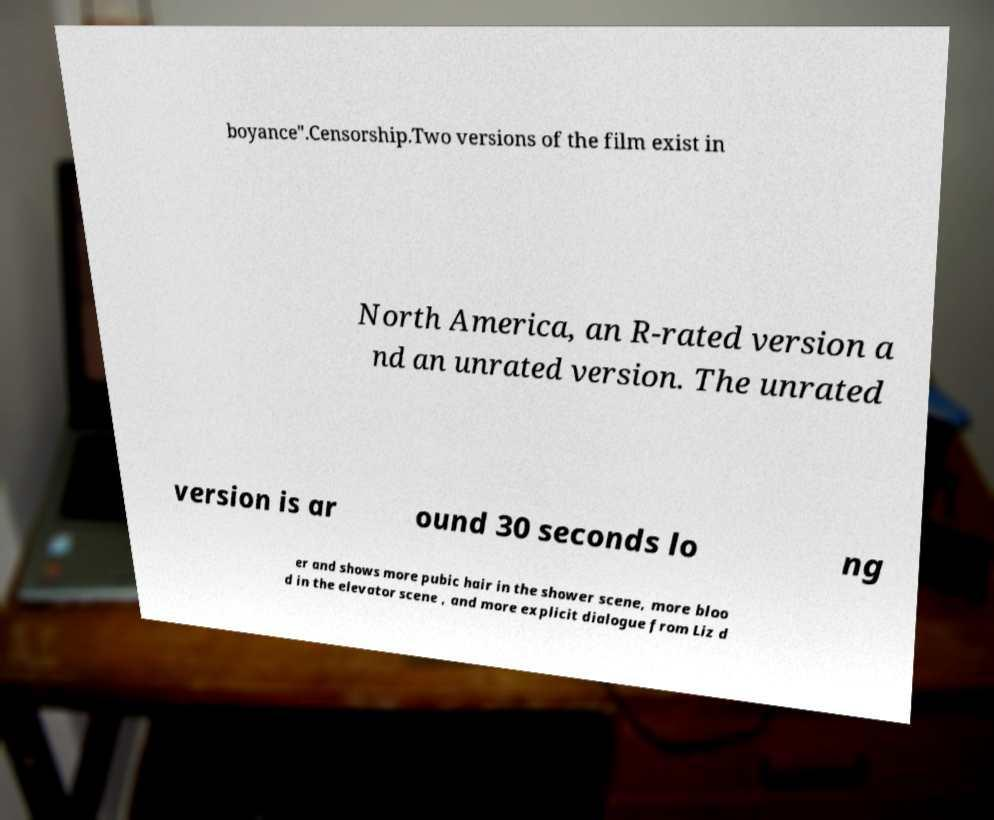Could you assist in decoding the text presented in this image and type it out clearly? boyance".Censorship.Two versions of the film exist in North America, an R-rated version a nd an unrated version. The unrated version is ar ound 30 seconds lo ng er and shows more pubic hair in the shower scene, more bloo d in the elevator scene , and more explicit dialogue from Liz d 